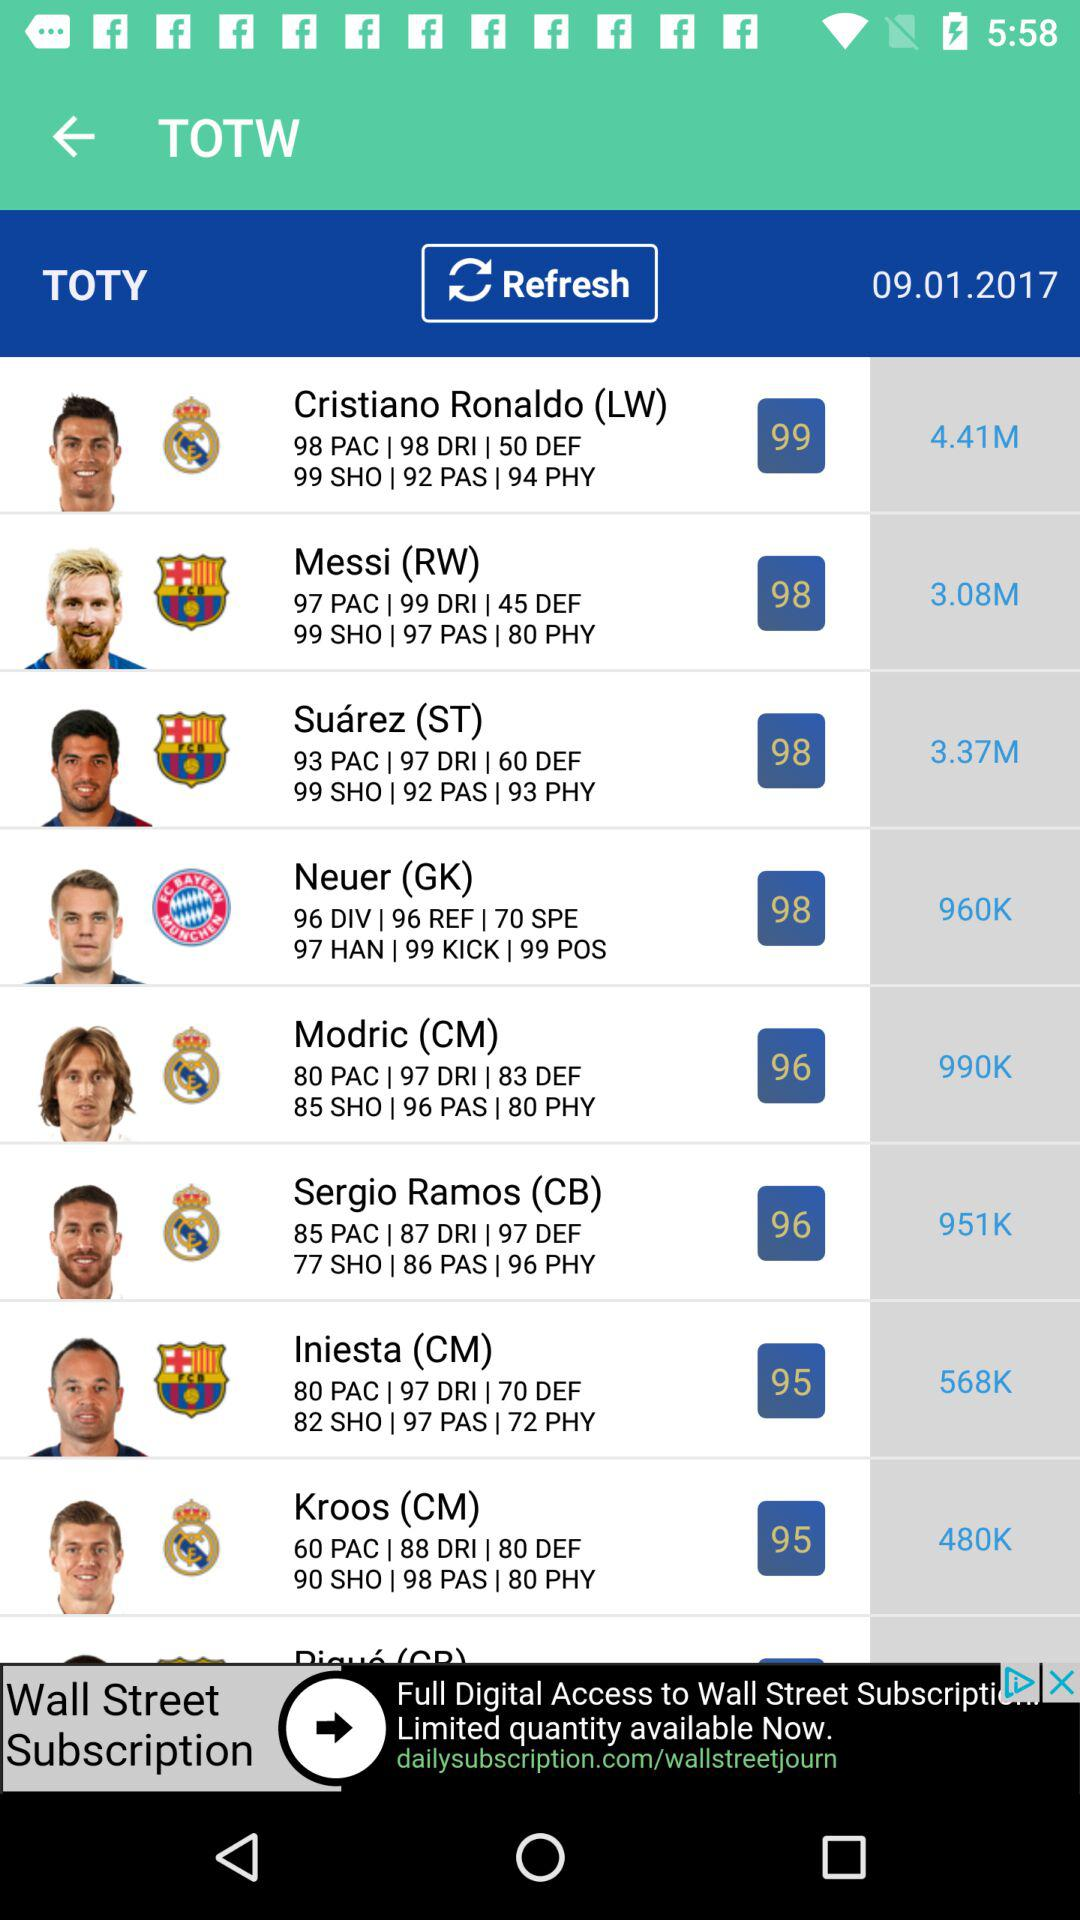What is the DEF of Modric? The DEF of Modric is 83. 